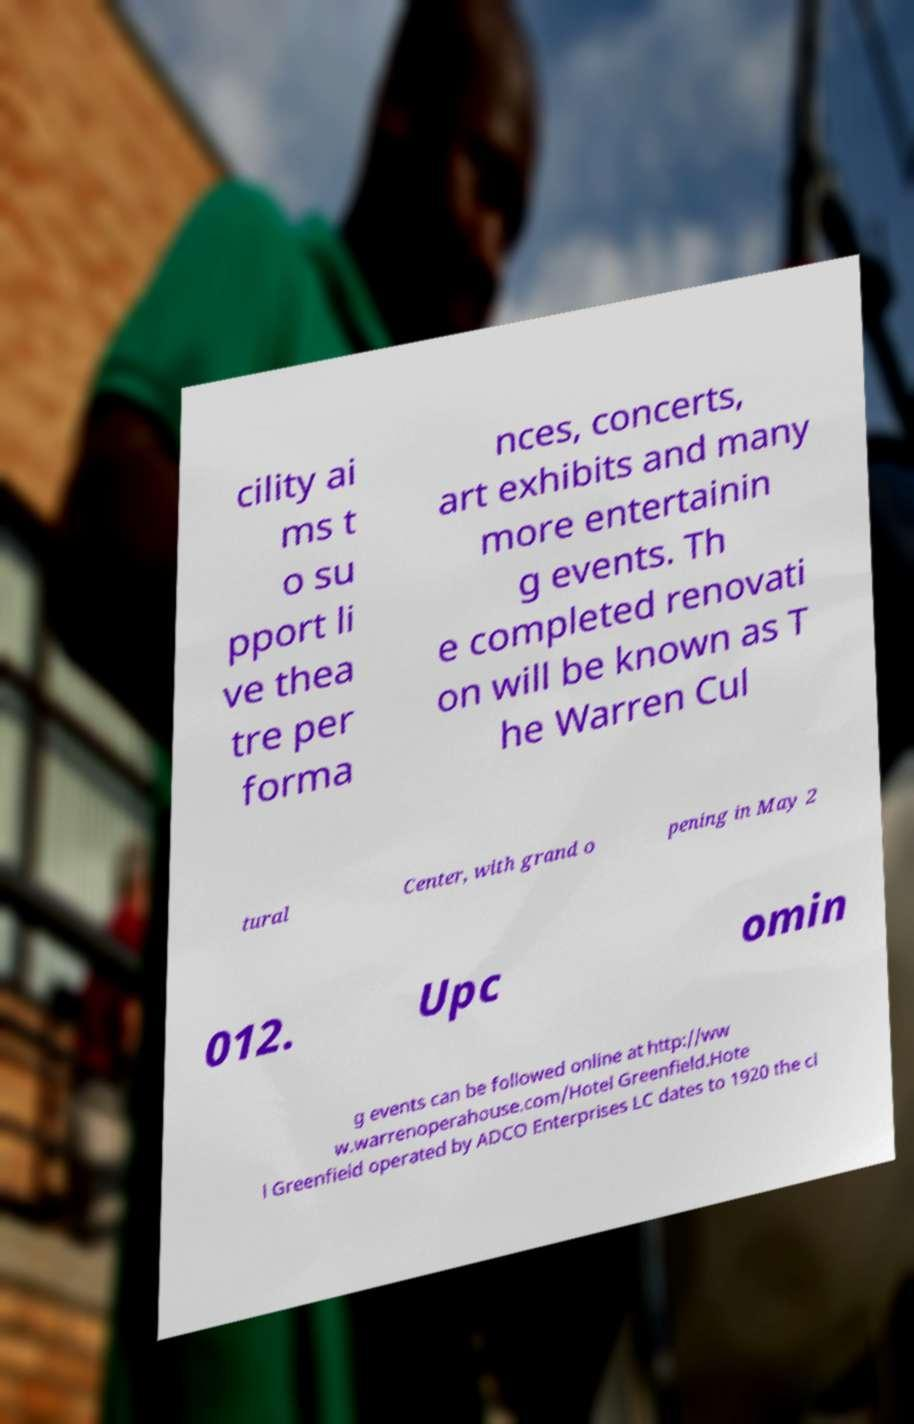Please read and relay the text visible in this image. What does it say? cility ai ms t o su pport li ve thea tre per forma nces, concerts, art exhibits and many more entertainin g events. Th e completed renovati on will be known as T he Warren Cul tural Center, with grand o pening in May 2 012. Upc omin g events can be followed online at http://ww w.warrenoperahouse.com/Hotel Greenfield.Hote l Greenfield operated by ADCO Enterprises LC dates to 1920 the ci 